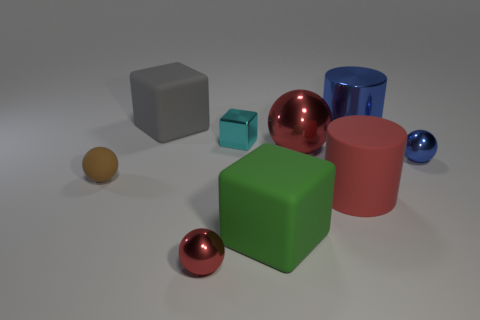There is a tiny thing that is the same shape as the big green matte object; what material is it?
Your answer should be very brief. Metal. There is a small thing that is the same color as the big rubber cylinder; what material is it?
Your answer should be compact. Metal. Are there fewer large cylinders than things?
Keep it short and to the point. Yes. There is a big block that is in front of the gray matte thing; does it have the same color as the tiny rubber sphere?
Give a very brief answer. No. What is the color of the tiny block that is the same material as the blue cylinder?
Give a very brief answer. Cyan. Does the blue cylinder have the same size as the brown thing?
Offer a very short reply. No. What is the material of the small blue sphere?
Your answer should be compact. Metal. There is a red sphere that is the same size as the red rubber cylinder; what is its material?
Ensure brevity in your answer.  Metal. Are there any gray blocks of the same size as the cyan shiny block?
Provide a short and direct response. No. Are there an equal number of small cubes in front of the tiny brown matte object and big gray rubber cubes left of the large green thing?
Your response must be concise. No. 